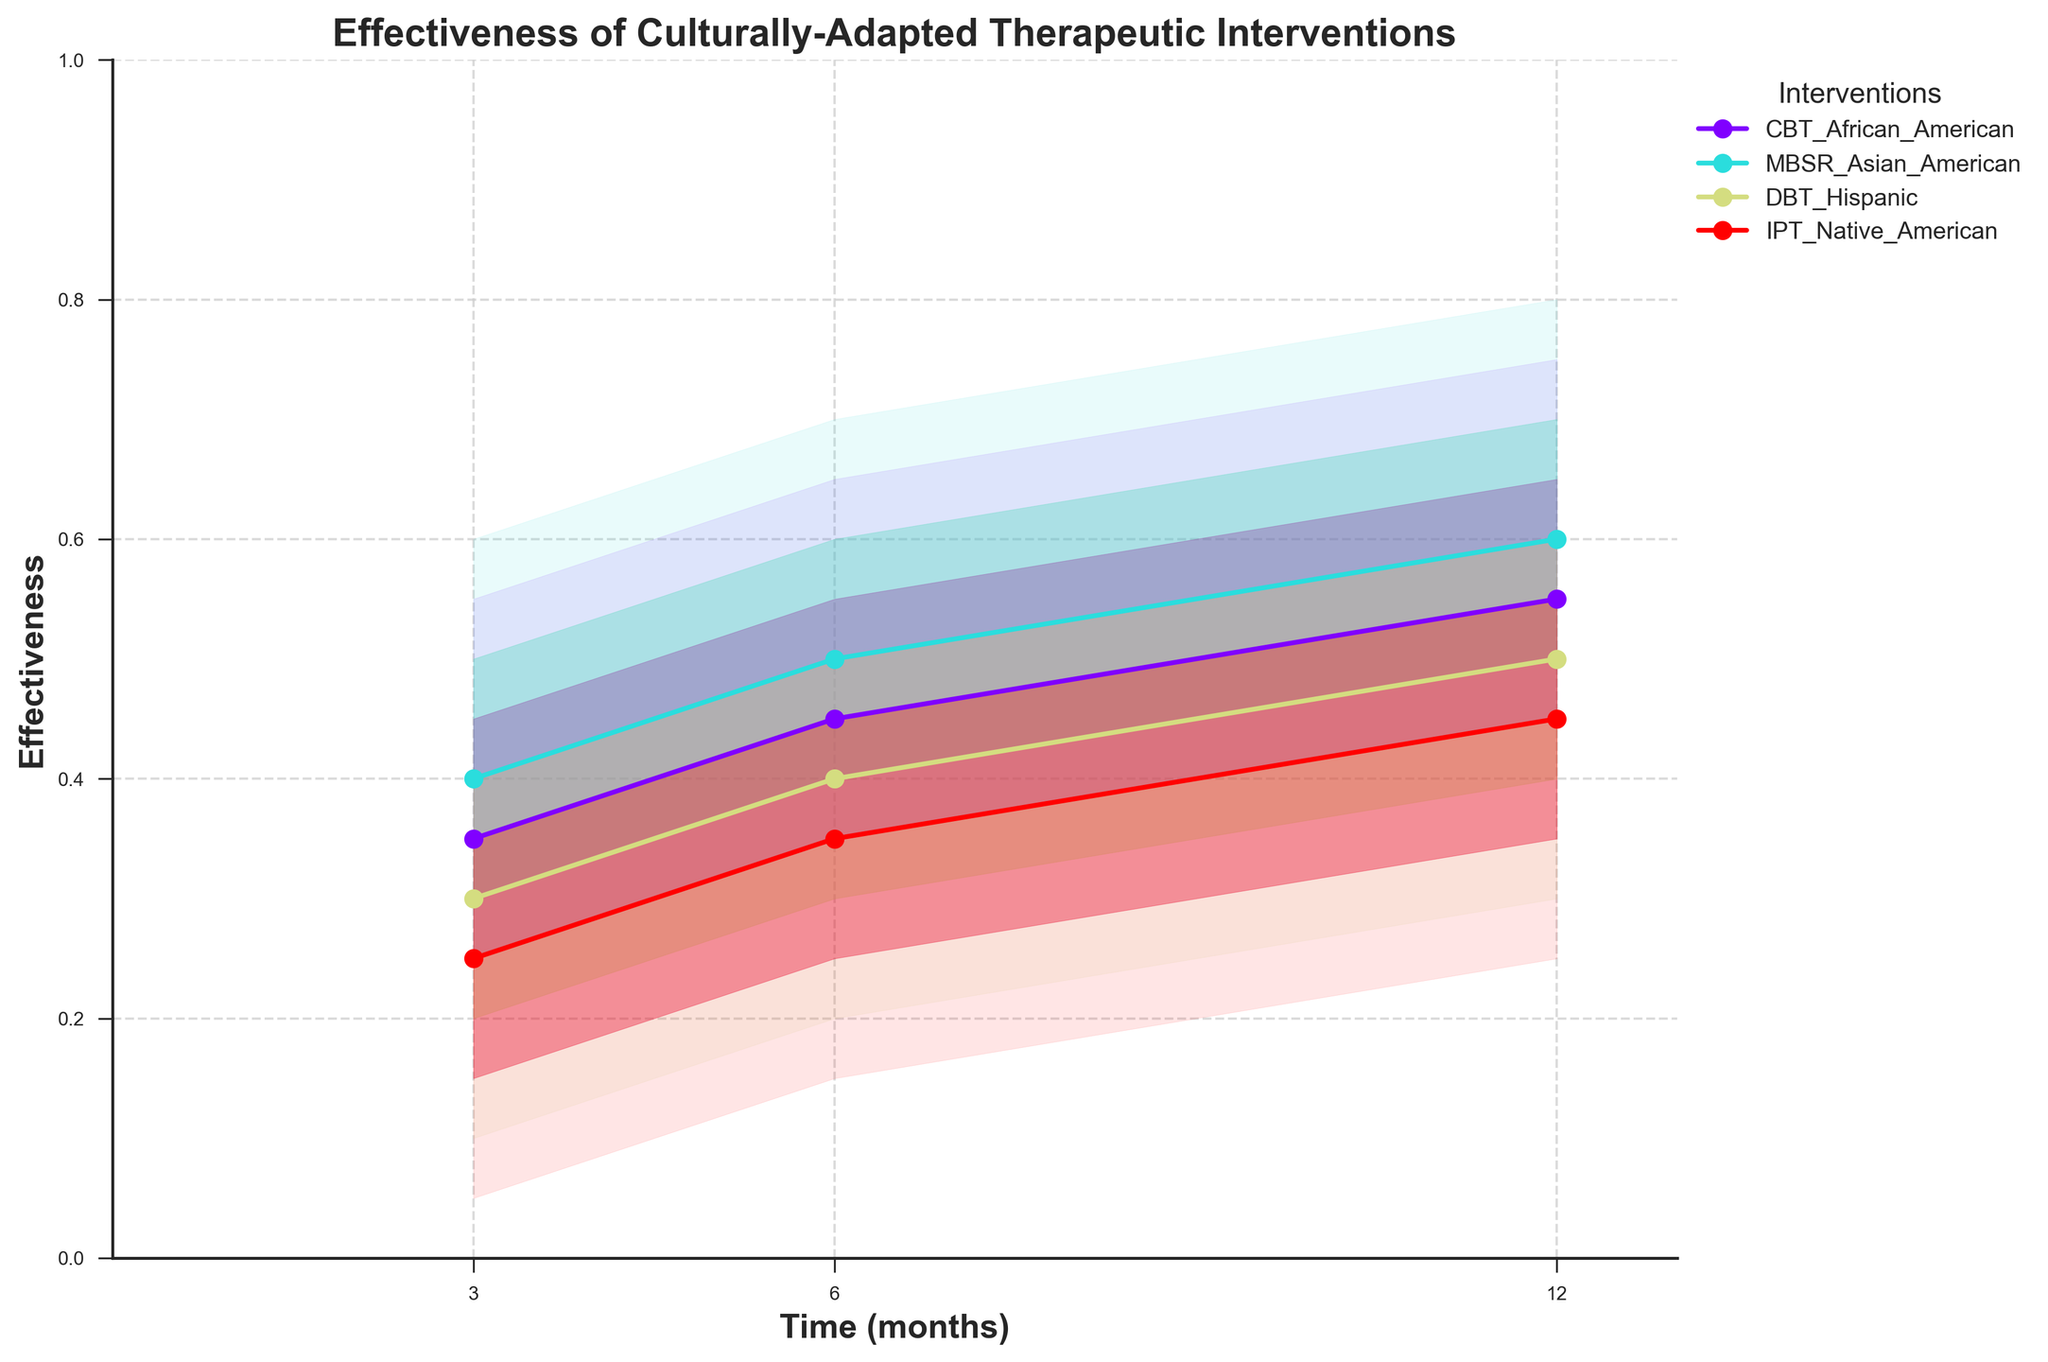What is the title of the figure? The title of the figure explicitly appears at the top and reads "Effectiveness of Culturally-Adapted Therapeutic Interventions".
Answer: Effectiveness of Culturally-Adapted Therapeutic Interventions Over which time periods were the therapeutic interventions observed? We can see the x-axis labeled as "Time (months)” with ticks at 3, 6, and 12 months.
Answer: 3, 6, and 12 months Which intervention has the highest median effectiveness at 3 months? By examining the points labeled on the y-axis for the median values at 3 months, CBT for African Americans has the highest value of 0.35.
Answer: CBT for African Americans What is the median effectiveness of MBSR for Asian Americans at 12 months? By looking at the solid line with markers for MBSR for Asian Americans at the 12-month mark, the median effectiveness is 0.60.
Answer: 0.60 How does the median effectiveness of DBT for Hispanics change from 3 to 12 months? The median effectiveness for DBT for Hispanics at 3 months is 0.30, increasing to 0.40 at 6 months, and reaching 0.50 at 12 months.
Answer: It increases from 0.30 to 0.50 Which intervention has the smallest range of effectiveness at 6 months within the 75% confidence interval? To find this, look at the width of the filled area between the lower and upper 75% CI at 6 months. CBT for African Americans (0.35 to 0.55) has the smallest range of 0.20.
Answer: CBT for African Americans Between which two interventions is there the most overlap in the 95% confidence interval at 12 months? Check the shaded areas corresponding to the upper and lower 95% CI at 12 months. MBSR for Asian Americans (0.40 to 0.80) and DBT for Hispanics (0.30 to 0.70) show the most overlap.
Answer: MBSR for Asian Americans and DBT for Hispanics What can be inferred about the effectiveness of IPT for Native Americans over time? We should look at the trend lines and confidence intervals of IPT for Native Americans which show a steady increase in median effectiveness from 0.25 at 3 months to 0.45 at 12 months. The confidence intervals also shift upward over time.
Answer: Median effectiveness steadily increases Which intervention shows the greatest increase in median effectiveness from 3 to 12 months? Compare the differences between the median values at 3 and 12 months for all interventions. MBSR for Asian Americans increases the most from 0.40 to 0.60, a total difference of 0.20.
Answer: MBSR for Asian Americans 